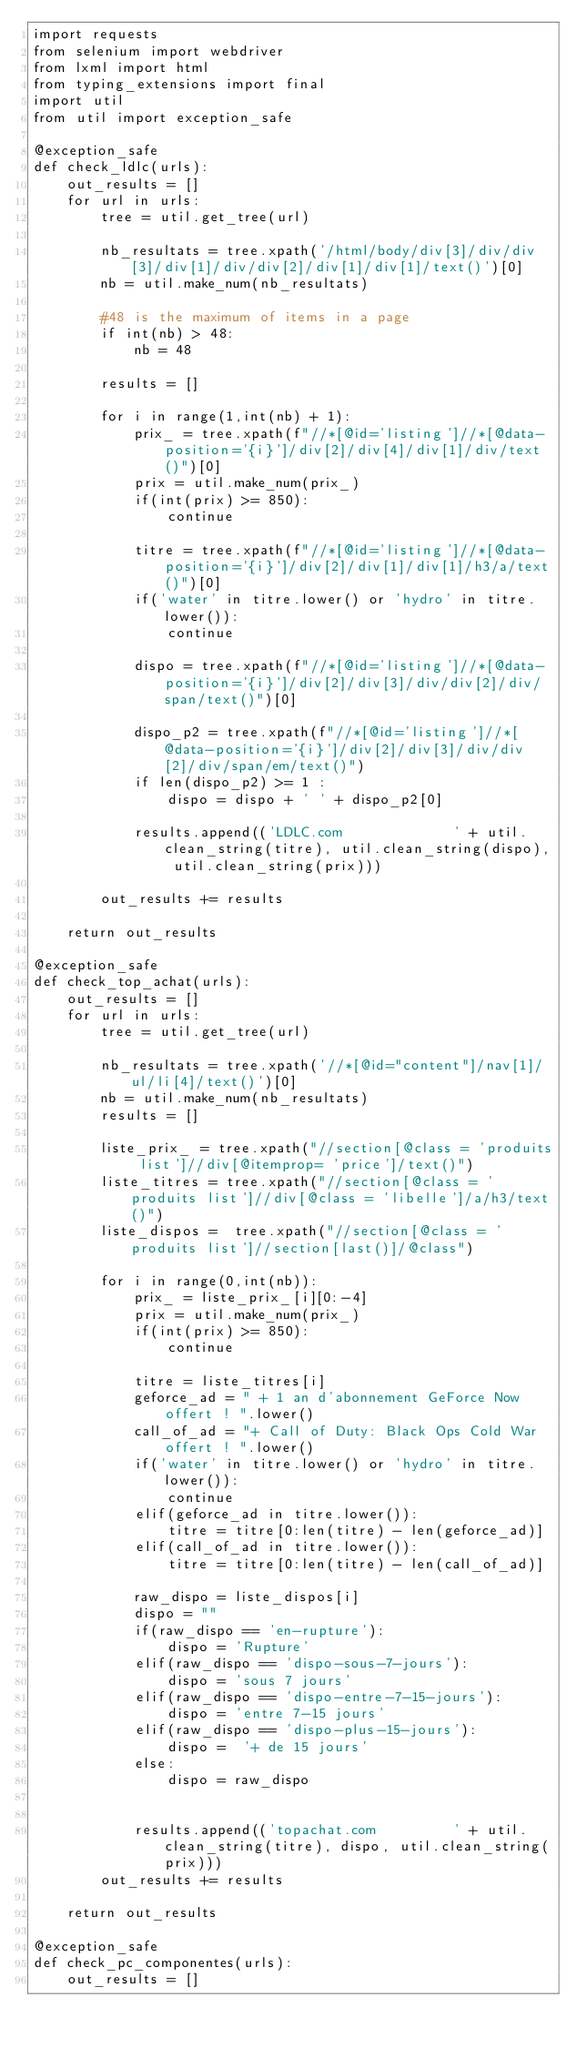<code> <loc_0><loc_0><loc_500><loc_500><_Python_>import requests
from selenium import webdriver
from lxml import html
from typing_extensions import final
import util
from util import exception_safe

@exception_safe
def check_ldlc(urls):
    out_results = []
    for url in urls:
        tree = util.get_tree(url)

        nb_resultats = tree.xpath('/html/body/div[3]/div/div[3]/div[1]/div/div[2]/div[1]/div[1]/text()')[0]
        nb = util.make_num(nb_resultats)

        #48 is the maximum of items in a page
        if int(nb) > 48:
            nb = 48

        results = []

        for i in range(1,int(nb) + 1):
            prix_ = tree.xpath(f"//*[@id='listing']//*[@data-position='{i}']/div[2]/div[4]/div[1]/div/text()")[0]
            prix = util.make_num(prix_)
            if(int(prix) >= 850):
                continue

            titre = tree.xpath(f"//*[@id='listing']//*[@data-position='{i}']/div[2]/div[1]/div[1]/h3/a/text()")[0]
            if('water' in titre.lower() or 'hydro' in titre.lower()):
                continue
            
            dispo = tree.xpath(f"//*[@id='listing']//*[@data-position='{i}']/div[2]/div[3]/div/div[2]/div/span/text()")[0]

            dispo_p2 = tree.xpath(f"//*[@id='listing']//*[@data-position='{i}']/div[2]/div[3]/div/div[2]/div/span/em/text()")
            if len(dispo_p2) >= 1 :
                dispo = dispo + ' ' + dispo_p2[0]

            results.append(('LDLC.com             ' + util.clean_string(titre), util.clean_string(dispo), util.clean_string(prix)))

        out_results += results
        
    return out_results

@exception_safe
def check_top_achat(urls):
    out_results = []
    for url in urls:
        tree = util.get_tree(url)

        nb_resultats = tree.xpath('//*[@id="content"]/nav[1]/ul/li[4]/text()')[0]
        nb = util.make_num(nb_resultats)
        results = []

        liste_prix_ = tree.xpath("//section[@class = 'produits list']//div[@itemprop= 'price']/text()")
        liste_titres = tree.xpath("//section[@class = 'produits list']//div[@class = 'libelle']/a/h3/text()")
        liste_dispos =  tree.xpath("//section[@class = 'produits list']//section[last()]/@class")
        
        for i in range(0,int(nb)):
            prix_ = liste_prix_[i][0:-4]
            prix = util.make_num(prix_)
            if(int(prix) >= 850):
                continue

            titre = liste_titres[i]
            geforce_ad = " + 1 an d'abonnement GeForce Now offert ! ".lower()
            call_of_ad = "+ Call of Duty: Black Ops Cold War offert ! ".lower()
            if('water' in titre.lower() or 'hydro' in titre.lower()):
                continue
            elif(geforce_ad in titre.lower()):
                titre = titre[0:len(titre) - len(geforce_ad)] 
            elif(call_of_ad in titre.lower()):
                titre = titre[0:len(titre) - len(call_of_ad)]

            raw_dispo = liste_dispos[i] 
            dispo = ""
            if(raw_dispo == 'en-rupture'):
                dispo = 'Rupture'
            elif(raw_dispo == 'dispo-sous-7-jours'):
                dispo = 'sous 7 jours'
            elif(raw_dispo == 'dispo-entre-7-15-jours'):
                dispo = 'entre 7-15 jours'
            elif(raw_dispo == 'dispo-plus-15-jours'):
                dispo =  '+ de 15 jours'
            else:
                dispo = raw_dispo


            results.append(('topachat.com         ' + util.clean_string(titre), dispo, util.clean_string(prix)))
        out_results += results

    return out_results

@exception_safe
def check_pc_componentes(urls):
    out_results = []</code> 